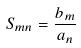<formula> <loc_0><loc_0><loc_500><loc_500>S _ { m n } = \frac { b _ { m } } { a _ { n } }</formula> 